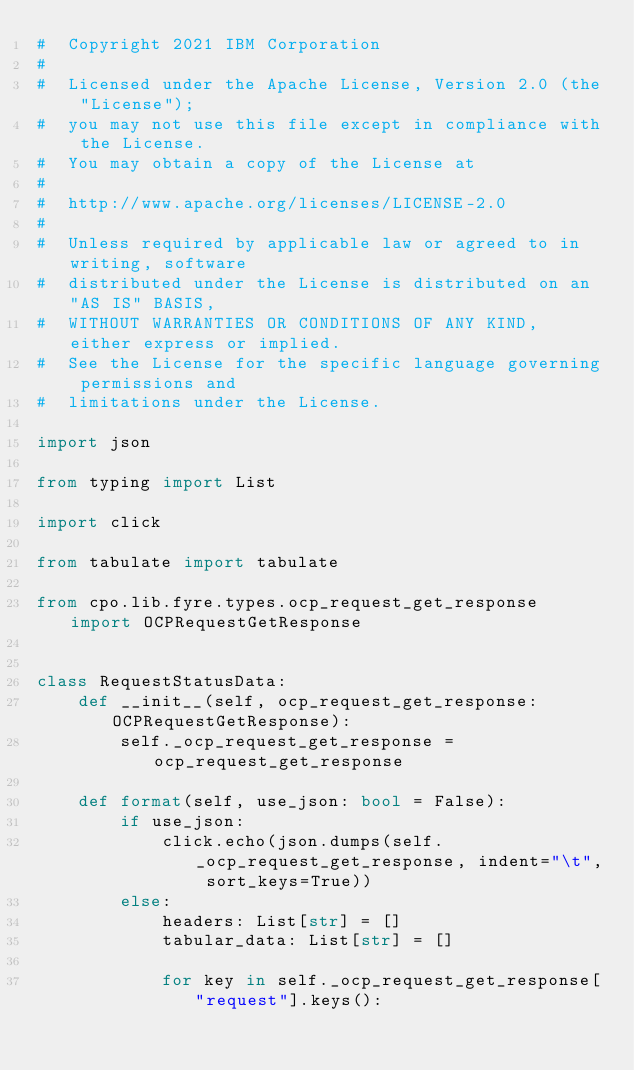Convert code to text. <code><loc_0><loc_0><loc_500><loc_500><_Python_>#  Copyright 2021 IBM Corporation
#
#  Licensed under the Apache License, Version 2.0 (the "License");
#  you may not use this file except in compliance with the License.
#  You may obtain a copy of the License at
#
#  http://www.apache.org/licenses/LICENSE-2.0
#
#  Unless required by applicable law or agreed to in writing, software
#  distributed under the License is distributed on an "AS IS" BASIS,
#  WITHOUT WARRANTIES OR CONDITIONS OF ANY KIND, either express or implied.
#  See the License for the specific language governing permissions and
#  limitations under the License.

import json

from typing import List

import click

from tabulate import tabulate

from cpo.lib.fyre.types.ocp_request_get_response import OCPRequestGetResponse


class RequestStatusData:
    def __init__(self, ocp_request_get_response: OCPRequestGetResponse):
        self._ocp_request_get_response = ocp_request_get_response

    def format(self, use_json: bool = False):
        if use_json:
            click.echo(json.dumps(self._ocp_request_get_response, indent="\t", sort_keys=True))
        else:
            headers: List[str] = []
            tabular_data: List[str] = []

            for key in self._ocp_request_get_response["request"].keys():</code> 